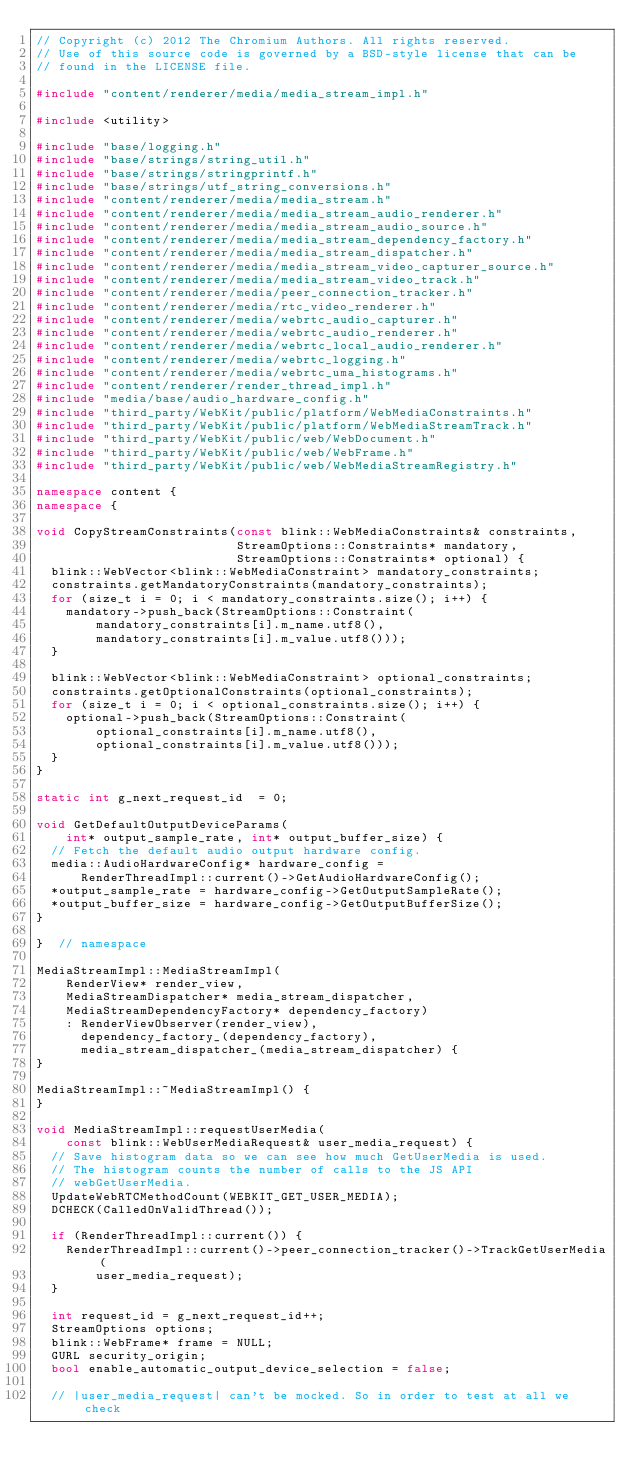Convert code to text. <code><loc_0><loc_0><loc_500><loc_500><_C++_>// Copyright (c) 2012 The Chromium Authors. All rights reserved.
// Use of this source code is governed by a BSD-style license that can be
// found in the LICENSE file.

#include "content/renderer/media/media_stream_impl.h"

#include <utility>

#include "base/logging.h"
#include "base/strings/string_util.h"
#include "base/strings/stringprintf.h"
#include "base/strings/utf_string_conversions.h"
#include "content/renderer/media/media_stream.h"
#include "content/renderer/media/media_stream_audio_renderer.h"
#include "content/renderer/media/media_stream_audio_source.h"
#include "content/renderer/media/media_stream_dependency_factory.h"
#include "content/renderer/media/media_stream_dispatcher.h"
#include "content/renderer/media/media_stream_video_capturer_source.h"
#include "content/renderer/media/media_stream_video_track.h"
#include "content/renderer/media/peer_connection_tracker.h"
#include "content/renderer/media/rtc_video_renderer.h"
#include "content/renderer/media/webrtc_audio_capturer.h"
#include "content/renderer/media/webrtc_audio_renderer.h"
#include "content/renderer/media/webrtc_local_audio_renderer.h"
#include "content/renderer/media/webrtc_logging.h"
#include "content/renderer/media/webrtc_uma_histograms.h"
#include "content/renderer/render_thread_impl.h"
#include "media/base/audio_hardware_config.h"
#include "third_party/WebKit/public/platform/WebMediaConstraints.h"
#include "third_party/WebKit/public/platform/WebMediaStreamTrack.h"
#include "third_party/WebKit/public/web/WebDocument.h"
#include "third_party/WebKit/public/web/WebFrame.h"
#include "third_party/WebKit/public/web/WebMediaStreamRegistry.h"

namespace content {
namespace {

void CopyStreamConstraints(const blink::WebMediaConstraints& constraints,
                           StreamOptions::Constraints* mandatory,
                           StreamOptions::Constraints* optional) {
  blink::WebVector<blink::WebMediaConstraint> mandatory_constraints;
  constraints.getMandatoryConstraints(mandatory_constraints);
  for (size_t i = 0; i < mandatory_constraints.size(); i++) {
    mandatory->push_back(StreamOptions::Constraint(
        mandatory_constraints[i].m_name.utf8(),
        mandatory_constraints[i].m_value.utf8()));
  }

  blink::WebVector<blink::WebMediaConstraint> optional_constraints;
  constraints.getOptionalConstraints(optional_constraints);
  for (size_t i = 0; i < optional_constraints.size(); i++) {
    optional->push_back(StreamOptions::Constraint(
        optional_constraints[i].m_name.utf8(),
        optional_constraints[i].m_value.utf8()));
  }
}

static int g_next_request_id  = 0;

void GetDefaultOutputDeviceParams(
    int* output_sample_rate, int* output_buffer_size) {
  // Fetch the default audio output hardware config.
  media::AudioHardwareConfig* hardware_config =
      RenderThreadImpl::current()->GetAudioHardwareConfig();
  *output_sample_rate = hardware_config->GetOutputSampleRate();
  *output_buffer_size = hardware_config->GetOutputBufferSize();
}

}  // namespace

MediaStreamImpl::MediaStreamImpl(
    RenderView* render_view,
    MediaStreamDispatcher* media_stream_dispatcher,
    MediaStreamDependencyFactory* dependency_factory)
    : RenderViewObserver(render_view),
      dependency_factory_(dependency_factory),
      media_stream_dispatcher_(media_stream_dispatcher) {
}

MediaStreamImpl::~MediaStreamImpl() {
}

void MediaStreamImpl::requestUserMedia(
    const blink::WebUserMediaRequest& user_media_request) {
  // Save histogram data so we can see how much GetUserMedia is used.
  // The histogram counts the number of calls to the JS API
  // webGetUserMedia.
  UpdateWebRTCMethodCount(WEBKIT_GET_USER_MEDIA);
  DCHECK(CalledOnValidThread());

  if (RenderThreadImpl::current()) {
    RenderThreadImpl::current()->peer_connection_tracker()->TrackGetUserMedia(
        user_media_request);
  }

  int request_id = g_next_request_id++;
  StreamOptions options;
  blink::WebFrame* frame = NULL;
  GURL security_origin;
  bool enable_automatic_output_device_selection = false;

  // |user_media_request| can't be mocked. So in order to test at all we check</code> 